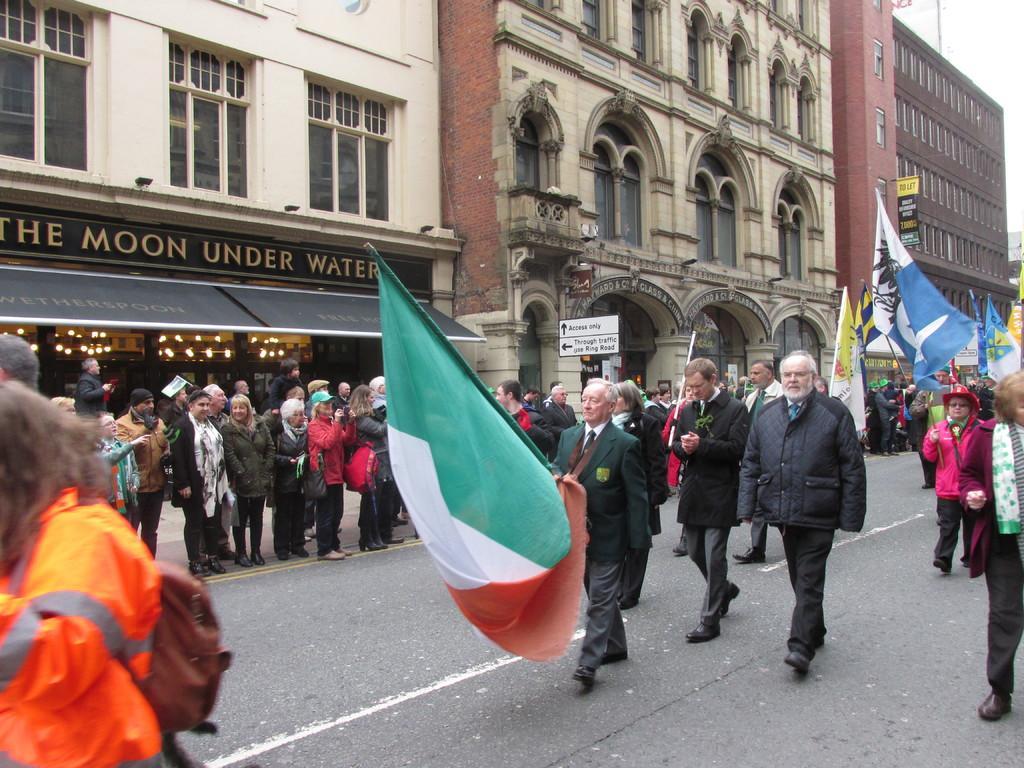In one or two sentences, can you explain what this image depicts? In this image there are a few people walking on the road, a few are standing and a few are holding flags in their hands. In the background there are buildings. 